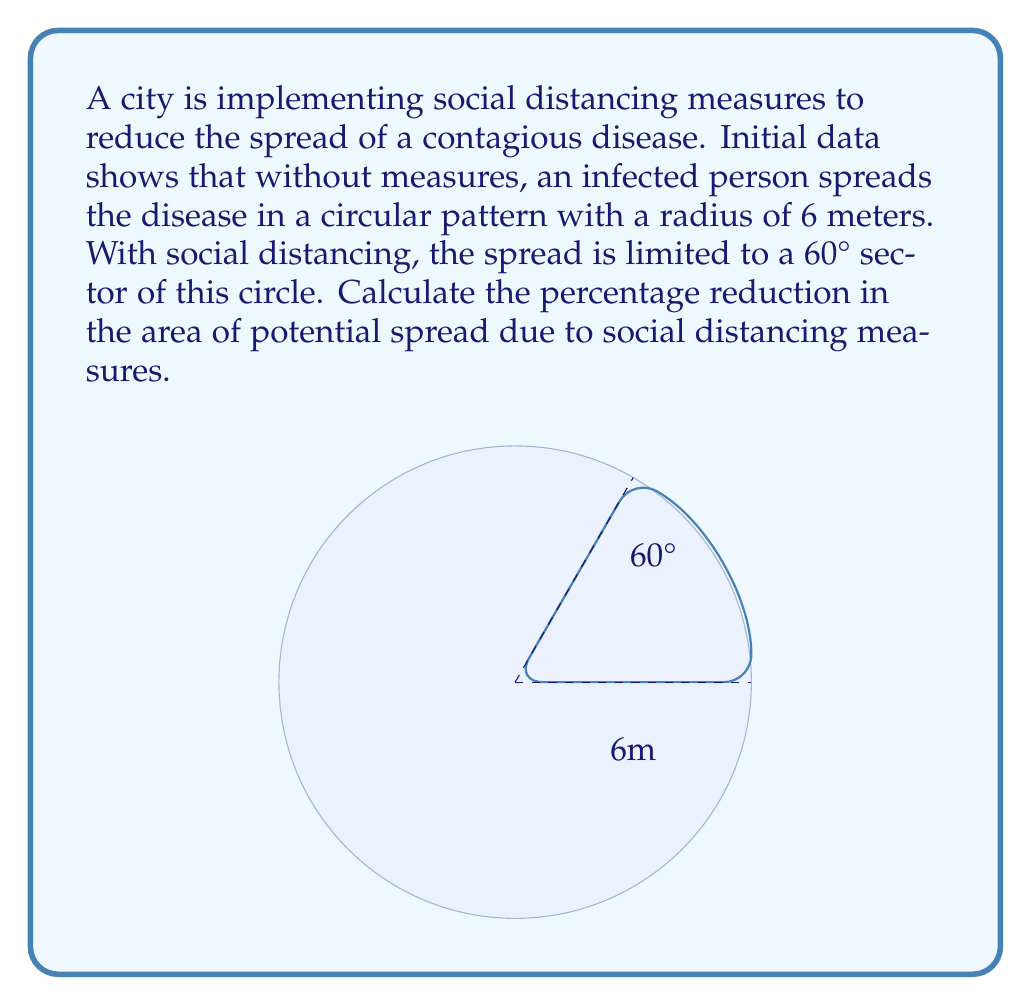Can you answer this question? To solve this problem, we need to compare the area of the full circle (without social distancing) to the area of the 60° sector (with social distancing).

1) Area of the full circle:
   $$A_{circle} = \pi r^2 = \pi (6^2) = 36\pi \text{ m}^2$$

2) Area of the 60° sector:
   The formula for the area of a sector is $A_{sector} = \frac{\theta}{360°} \pi r^2$, where $\theta$ is the central angle in degrees.
   $$A_{sector} = \frac{60°}{360°} \pi (6^2) = \frac{1}{6} (36\pi) = 6\pi \text{ m}^2$$

3) Calculate the reduction in area:
   $$\text{Reduction} = A_{circle} - A_{sector} = 36\pi - 6\pi = 30\pi \text{ m}^2$$

4) Calculate the percentage reduction:
   $$\text{Percentage Reduction} = \frac{\text{Reduction}}{A_{circle}} \times 100\%$$
   $$= \frac{30\pi}{36\pi} \times 100\% = \frac{5}{6} \times 100\% = 83.33\%$$

Therefore, the social distancing measures reduce the area of potential spread by approximately 83.33%.
Answer: 83.33% 